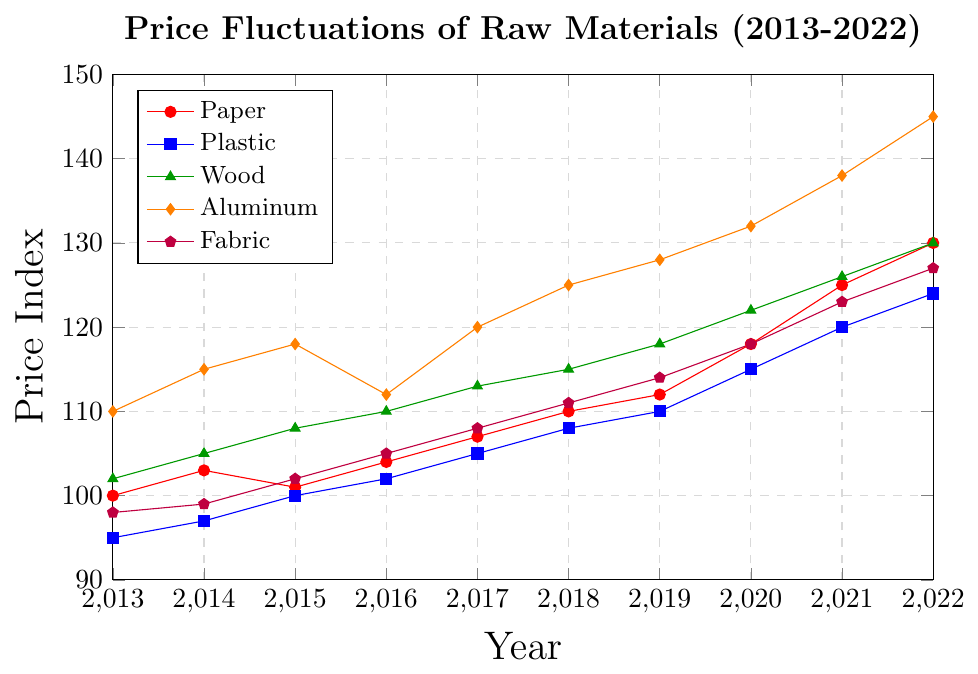Which material had the highest price index in 2022? Observe the endpoints for each material on the right side of the chart. The highest endpoint in 2022 is for Aluminum with a price index of 145.
Answer: Aluminum What was the price index of Paper in 2015? Locate the year 2015 on the x-axis and follow it vertically until it intersects with the Paper line (red). The intersection is at the price index of 101.
Answer: 101 How much did the price index of Fabric change from 2013 to 2022? Find the price index of Fabric (purple) in 2013 and 2022, which are 98 and 127 respectively. Subtract the initial value from the final value (127 - 98).
Answer: 29 Between Plastic and Wood, which one had a higher price index in 2018? Locate the year 2018 on the x-axis, then find the points for Plastic (blue) and Wood (green) at this year. Plastic is 108, and Wood is 115. Wood has a higher price index.
Answer: Wood What was the average price index for Aluminum from 2014 to 2016? Identify the price indices of Aluminum (orange) in 2014, 2015, and 2016, which are 115, 118, and 112 respectively. Then, add these values and divide by 3. (115 + 118 + 112) / 3 = 115
Answer: 115 Which material had the most stable price trend over the decade? Observe the lines' overall yearly changes on the chart. The line with the smallest fluctuations is for Fabric (purple).
Answer: Fabric What is the difference in the price index of Plastic between 2020 and 2021? Find the price indices for Plastic (blue) in 2020 and 2021, which are 115 and 120 respectively. Subtract the 2020 value from the 2021 value (120 - 115).
Answer: 5 How many materials had a price index over 120 in 2022? Locate the year 2022 on the x-axis and check the corresponding indices for each material. Paper (130), Aluminum (145), and Fabric (127) all have indices over 120. There are 3 such materials.
Answer: 3 During which year did Wood's price index first reach 110? Follow the Wood line (green) and identify the point where it first intersects the 110 price index level. This occurs in the year 2016.
Answer: 2016 